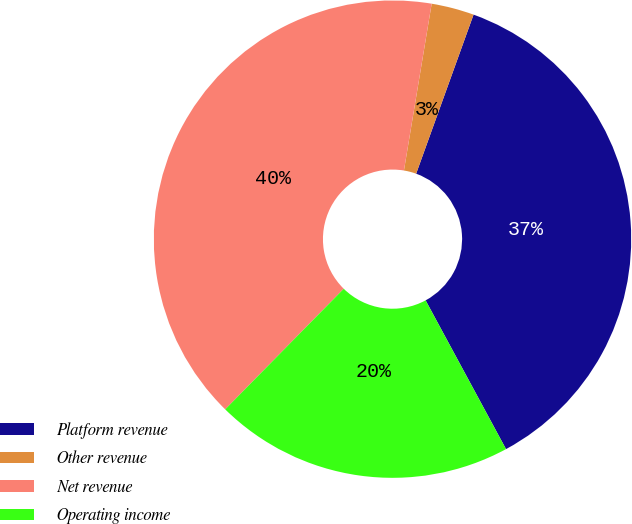Convert chart to OTSL. <chart><loc_0><loc_0><loc_500><loc_500><pie_chart><fcel>Platform revenue<fcel>Other revenue<fcel>Net revenue<fcel>Operating income<nl><fcel>36.6%<fcel>2.89%<fcel>40.26%<fcel>20.25%<nl></chart> 